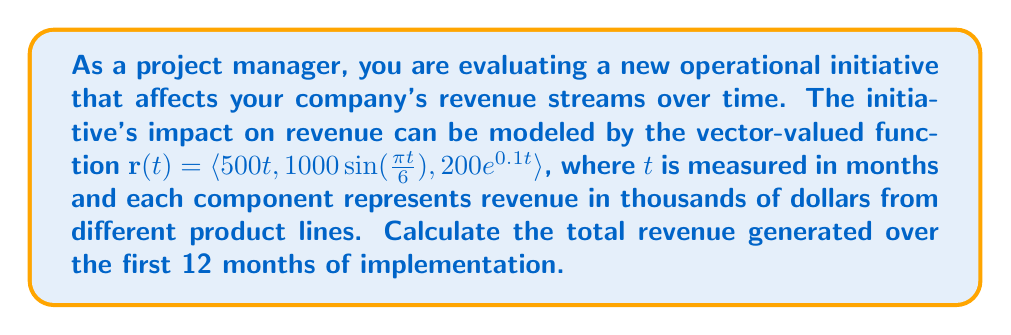Can you answer this question? To solve this problem, we need to follow these steps:

1) The vector-valued function $\mathbf{r}(t)$ represents the revenue streams from three different product lines:
   - $r_1(t) = 500t$
   - $r_2(t) = 1000\sin(\frac{\pi t}{6})$
   - $r_3(t) = 200e^{0.1t}$

2) To find the total revenue over time, we need to integrate each component of the vector-valued function from $t=0$ to $t=12$:

   $$\text{Total Revenue} = \int_0^{12} (r_1(t) + r_2(t) + r_3(t)) dt$$

3) Let's integrate each component separately:

   For $r_1(t)$:
   $$\int_0^{12} 500t \, dt = 500 \cdot \frac{t^2}{2} \bigg|_0^{12} = 500 \cdot \frac{144}{2} = 36,000$$

   For $r_2(t)$:
   $$\int_0^{12} 1000\sin(\frac{\pi t}{6}) \, dt = -\frac{6000}{\pi} \cos(\frac{\pi t}{6}) \bigg|_0^{12} = -\frac{6000}{\pi} (\cos(2\pi) - 1) = 0$$

   For $r_3(t)$:
   $$\int_0^{12} 200e^{0.1t} \, dt = 2000 \cdot \frac{e^{0.1t}}{0.1} \bigg|_0^{12} = 2000 \cdot 10 \cdot (e^{1.2} - 1) \approx 66,589.87$$

4) Sum up all the integrated components:
   $$\text{Total Revenue} = 36,000 + 0 + 66,589.87 = 102,589.87$$

Therefore, the total revenue generated over the first 12 months is approximately $102,589,870.
Answer: $102,589,870 